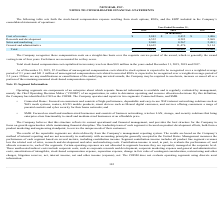According to Netgear's financial document, Which years was the total stock-based compensation cost capitalized in inventory less than $0.8 million? According to the financial document, 2019, 2018 and 2017. The relevant text states: "than $0.8 million in the years ended December 31, 2019, 2018 and 2017...." Also, What was the research and development expense in 2019? According to the financial document, 6,532 (in thousands). The relevant text states: "Research and development 6,532 4,283 2,968..." Also, can you calculate: What was the percentage change in cost of revenue from 2018 to 2019? To answer this question, I need to perform calculations using the financial data. The calculation is: ($2,843 - $2,435)/$2,435 , which equals 16.76 (percentage). This is based on the information: "Cost of revenue $ 2,843 $ 2,435 $ 1,406 Cost of revenue $ 2,843 $ 2,435 $ 1,406..." The key data points involved are: 2,435, 2,843. Additionally, Which year has the highest general and administrative expense? According to the financial document, 2018. The relevant text states: "2019 2018 2017..." Also, can you calculate: What was the change in sales and marketing expenses from 2017 to 2018? Based on the calculation: 8,267 -  5,481 , the result is 2786 (in thousands). This is based on the information: "Sales and marketing 9,069 8,267 5,481 Sales and marketing 9,069 8,267 5,481..." The key data points involved are: 5,481, 8,267. Also, What may be required of the company if there are any modifications or cancellations of the underlying unvested awards? May be required to accelerate, increase or cancel all or a portion of the remaining unearned stock-based compensation expense.. The document states: "ons of the underlying unvested awards, the Company may be required to accelerate, increase or cancel all or a portion of the remaining unearned stock-..." 